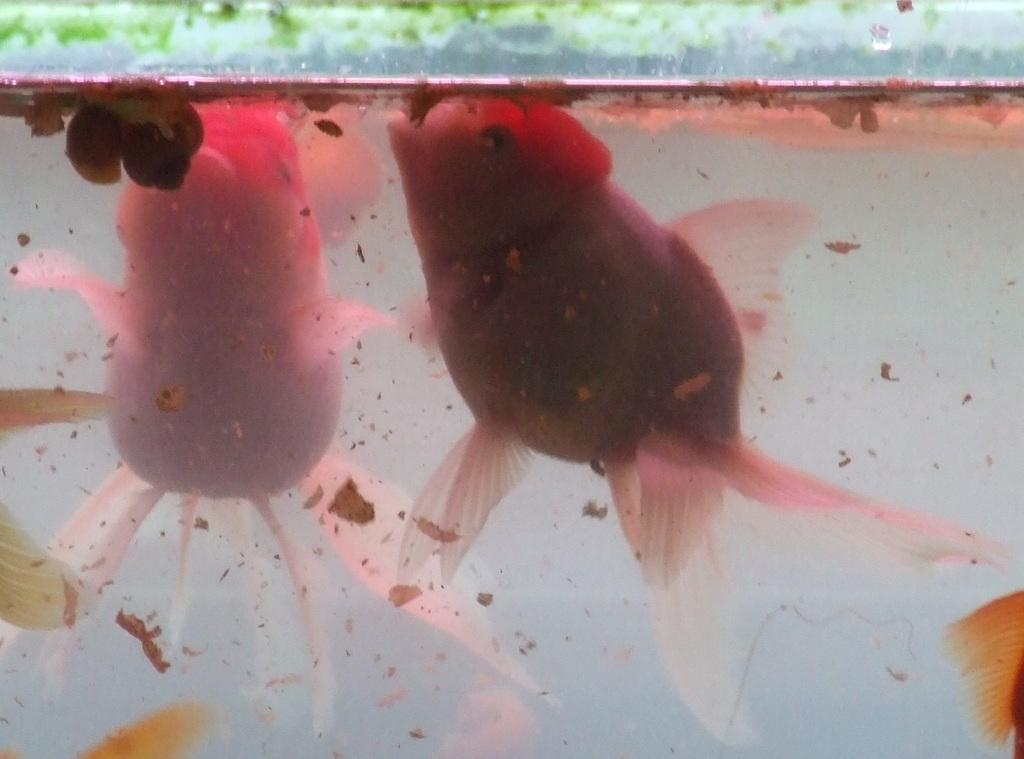What animals can be seen in the water in the image? There are two fish in the water. What else can be found in the water besides the fish? There are objects in the water. What type of leg can be seen on the robin in the image? There is no robin present in the image; it only features two fish and objects in the water. 